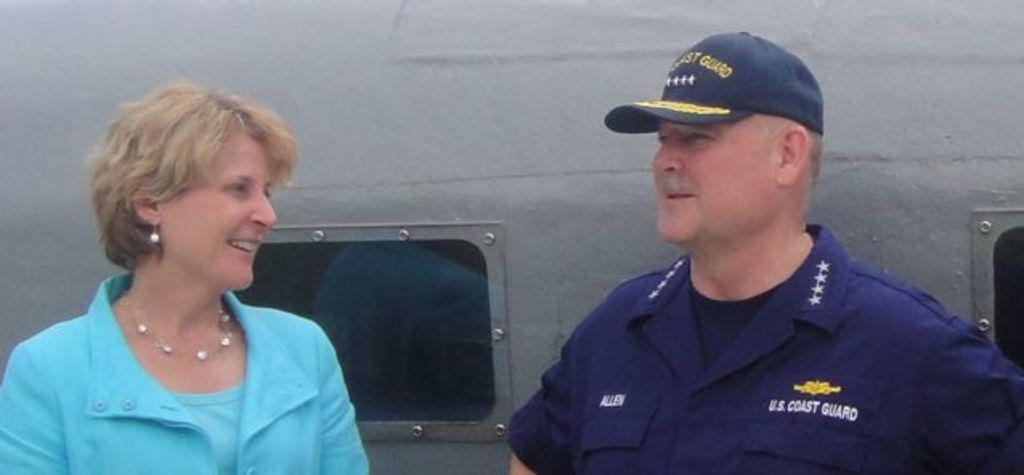<image>
Share a concise interpretation of the image provided. A man named Allen works for the U.S. Coast Guard. 